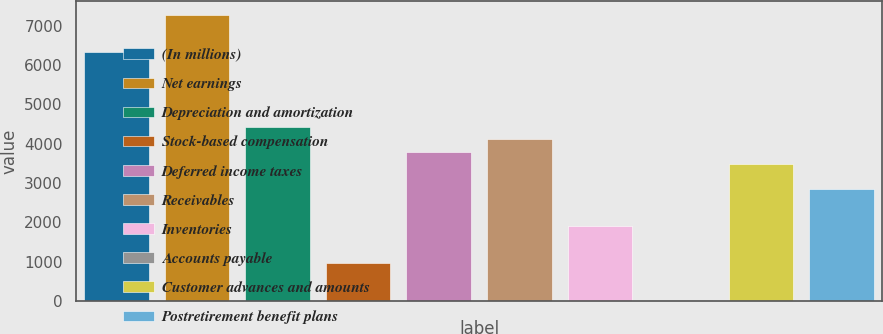<chart> <loc_0><loc_0><loc_500><loc_500><bar_chart><fcel>(In millions)<fcel>Net earnings<fcel>Depreciation and amortization<fcel>Stock-based compensation<fcel>Deferred income taxes<fcel>Receivables<fcel>Inventories<fcel>Accounts payable<fcel>Customer advances and amounts<fcel>Postretirement benefit plans<nl><fcel>6325<fcel>7270.6<fcel>4433.8<fcel>966.6<fcel>3803.4<fcel>4118.6<fcel>1912.2<fcel>21<fcel>3488.2<fcel>2857.8<nl></chart> 